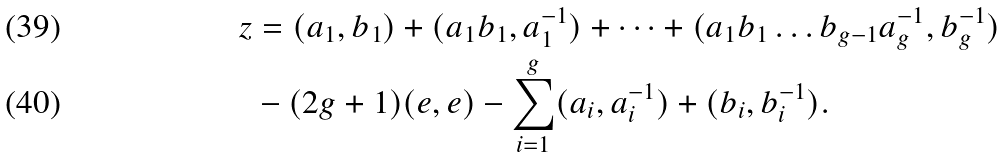<formula> <loc_0><loc_0><loc_500><loc_500>z & = ( a _ { 1 } , b _ { 1 } ) + ( a _ { 1 } b _ { 1 } , a _ { 1 } ^ { - 1 } ) + \dots + ( a _ { 1 } b _ { 1 } \dots b _ { g - 1 } a _ { g } ^ { - 1 } , b _ { g } ^ { - 1 } ) \\ & - ( 2 g + 1 ) ( e , e ) - \sum _ { i = 1 } ^ { g } ( a _ { i } , a _ { i } ^ { - 1 } ) + ( b _ { i } , b _ { i } ^ { - 1 } ) .</formula> 